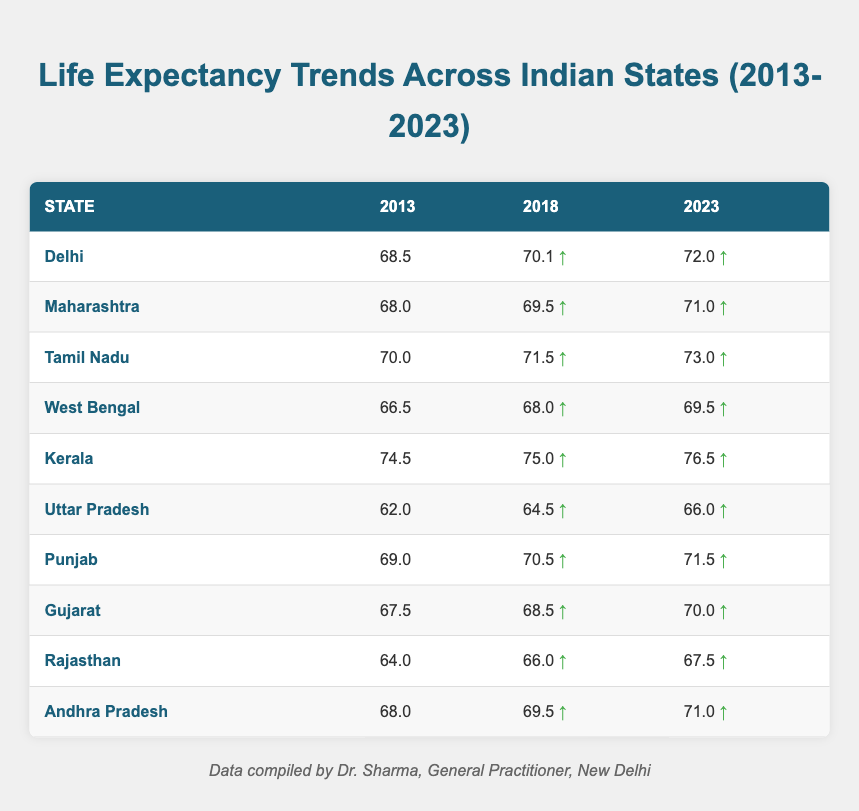What was the life expectancy in Kerala in 2023? According to the table, the life expectancy in Kerala in 2023 is directly listed as 76.5.
Answer: 76.5 Which state had the lowest life expectancy in 2013? From the data, Uttar Pradesh had the lowest life expectancy in 2013 at 62.0.
Answer: Uttar Pradesh What is the total increase in life expectancy for Tamil Nadu from 2013 to 2023? For Tamil Nadu, the life expectancy in 2013 was 70.0, and in 2023 it rose to 73.0. The increase is calculated as 73.0 - 70.0 = 3.0.
Answer: 3.0 Did Gujarat have a life expectancy higher than Maharashtra in 2018? In 2018, Gujarat’s life expectancy was 68.5, while Maharashtra’s was 69.5. Since 68.5 is less than 69.5, the answer is no.
Answer: No What is the average life expectancy across all states listed for the year 2023? Summing the life expectancies for 2023: (72.0 + 71.0 + 73.0 + 69.5 + 76.5 + 66.0 + 71.5 + 70.0 + 67.5 + 71.0) =  750.0. There are 10 states, so the average is 750.0 / 10 = 75.0.
Answer: 75.0 